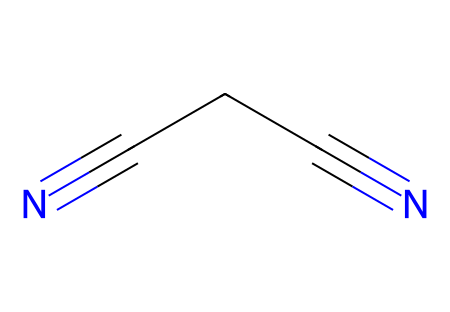How many carbon atoms are in succinonitrile? The chemical has the SMILES representation N#CCC#N. By interpreting the structure, we see the 'C' characters, which indicate carbon atoms. There are two 'C' characters present, meaning there are two carbon atoms in this structure.
Answer: 2 What is the primary functional group in succinonitrile? The SMILES notation shows that there are two cyano groups (N#C). The presence of these cyano groups (-C≡N) defines the chemical as a nitrile, which is the primary functional group.
Answer: nitrile How many double bonds are in succinonitrile? In the SMILES string, the 'C#N' indicates a triple bond between carbon and nitrogen at each cyano end. The structure does not exhibit any additional double bonds; hence, the total count of double bonds is zero.
Answer: 0 What is the total number of hydrogen atoms in succinonitrile? A nitrile typically does not have hydrogen directly attached to the carbon involved in the cyano group (C≡N). This molecule has a total of 0 hydrogen atoms because all valences of the carbon atoms are satisfied by the cyano groups.
Answer: 0 How many nitrogen atoms are in succinonitrile? Inspecting the SMILES notation N#CCC#N shows two 'N' characters. This indicates that there are two nitrogen atoms present in the structure, each located at the cyano ends.
Answer: 2 What is the length of carbon-carbon bonds in succinonitrile? The carbon-carbon bonds in this molecule are single bonds connecting the two carbon atoms; typically, this bond has a bond length of around 1.54 Å. This is a standard value for single carbon-carbon bonds in organic compounds.
Answer: 1.54 Å 